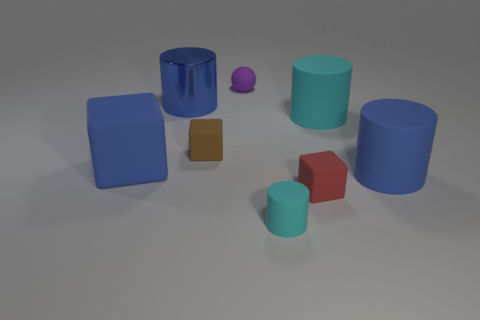Are there any blue matte cylinders that have the same size as the red matte block?
Provide a succinct answer. No. What material is the large blue cylinder that is in front of the blue cylinder that is on the left side of the small rubber block in front of the blue matte block?
Make the answer very short. Rubber. What number of brown blocks are right of the large blue matte object right of the brown thing?
Your answer should be compact. 0. There is a cyan cylinder behind the brown cube; does it have the same size as the tiny sphere?
Make the answer very short. No. What number of other things are the same shape as the tiny brown thing?
Provide a succinct answer. 2. The big cyan thing is what shape?
Provide a short and direct response. Cylinder. Are there the same number of small things in front of the brown rubber block and large gray metal things?
Offer a very short reply. No. Is there anything else that has the same material as the purple thing?
Your answer should be compact. Yes. Is the material of the object left of the metal cylinder the same as the tiny cyan cylinder?
Make the answer very short. Yes. Are there fewer large blue rubber cylinders to the left of the blue matte block than brown blocks?
Make the answer very short. Yes. 